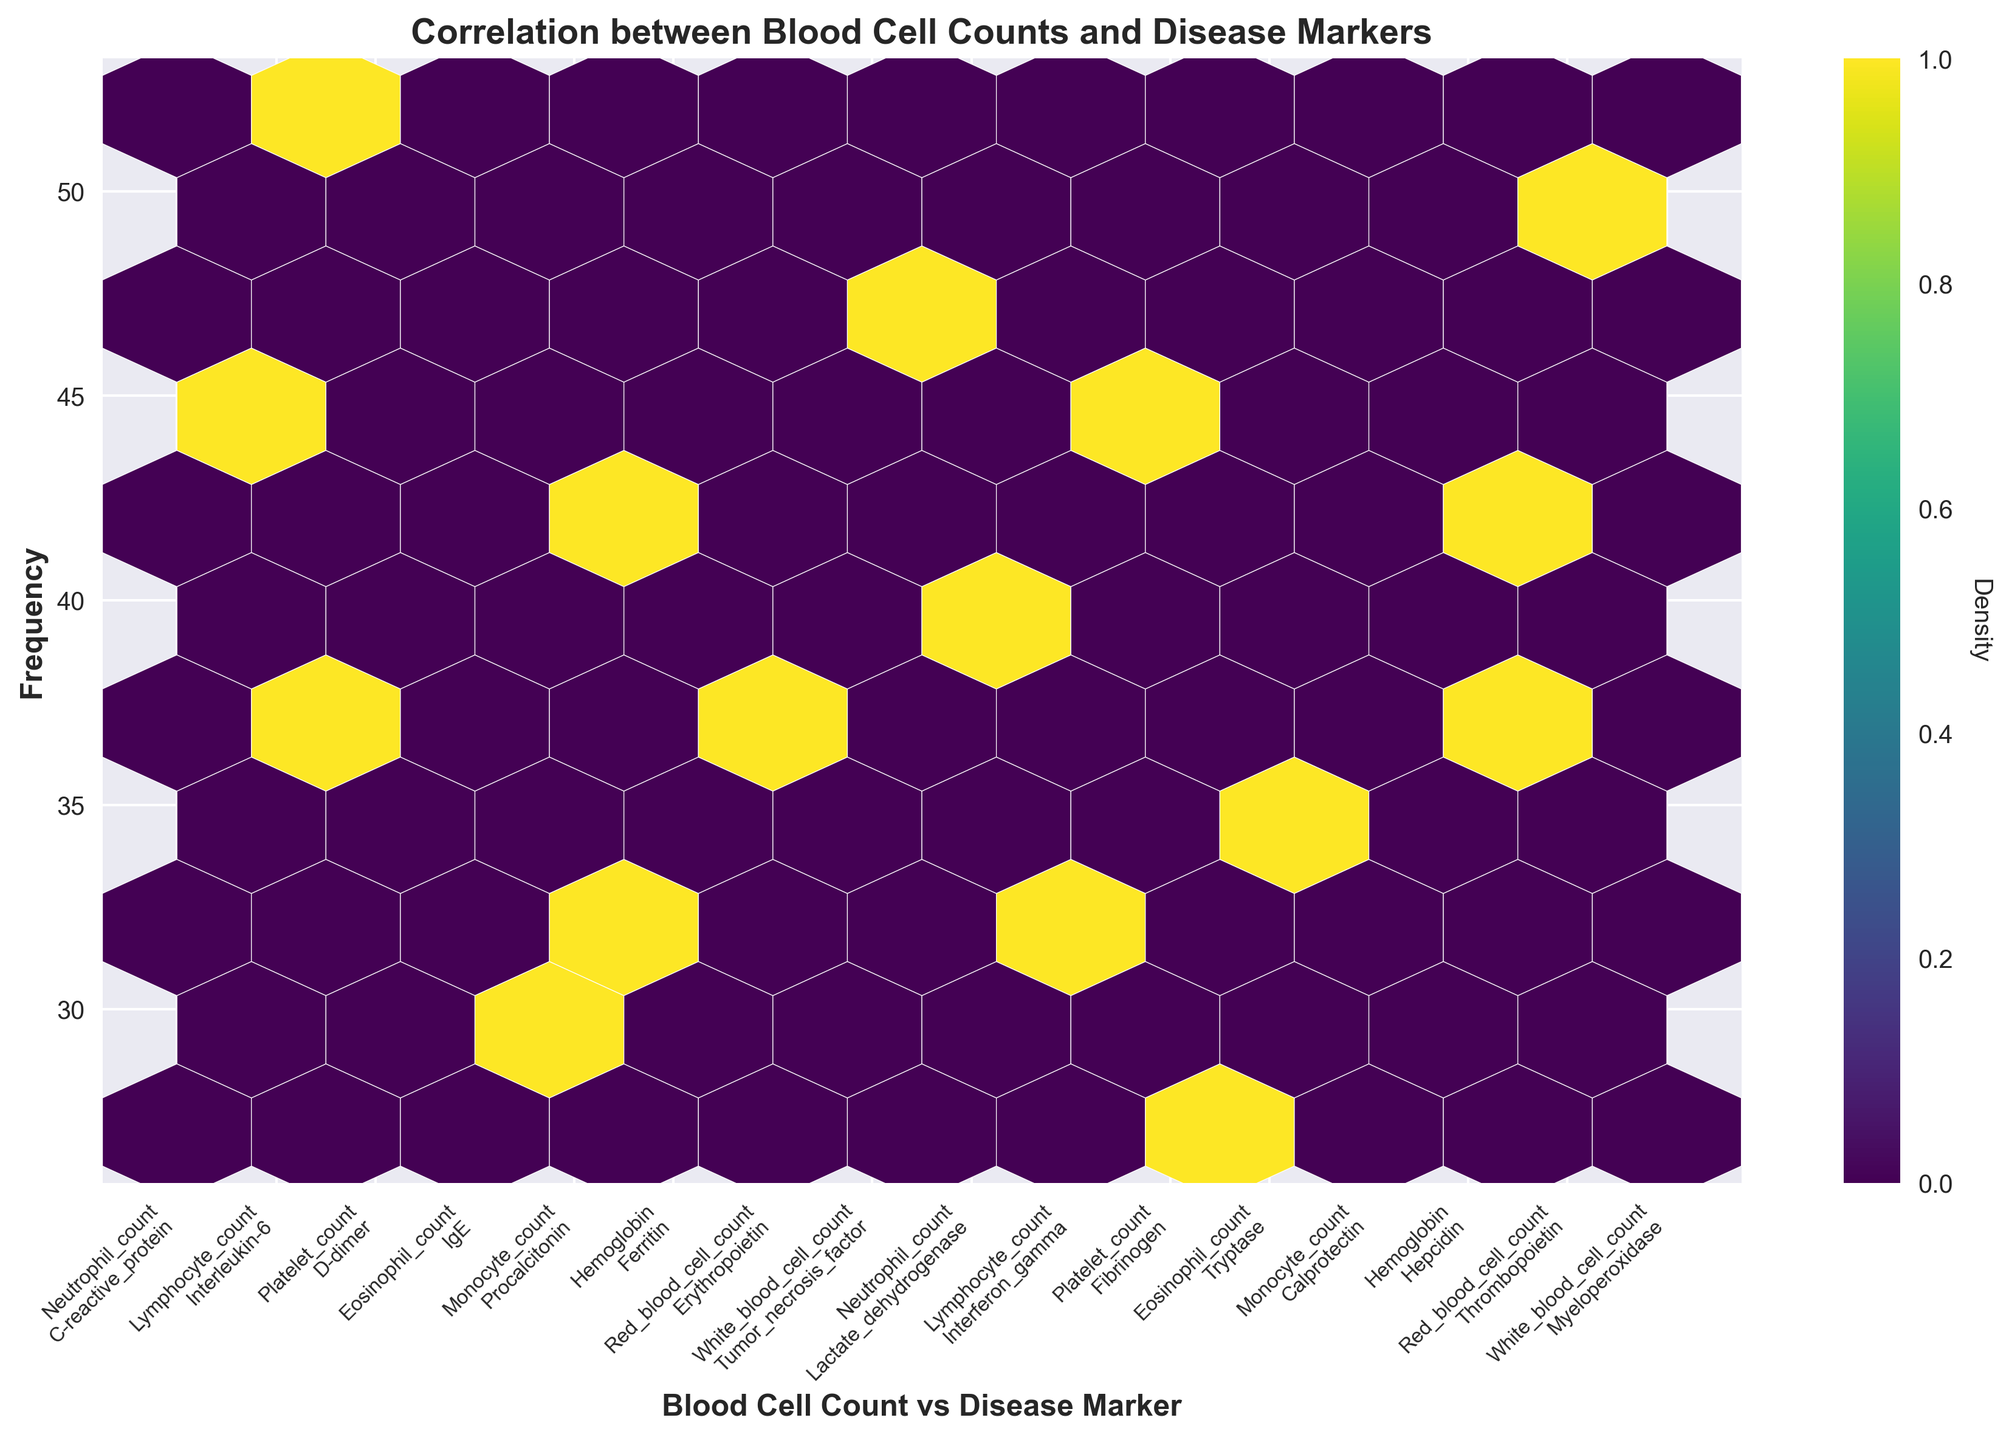What is the title of the hexbin plot? The title is displayed at the top-center of the plot and provides an overview of what the plot represents.
Answer: Correlation between Blood Cell Counts and Disease Markers What are the axes labels in the plot? The x-axis label is shown at the bottom and the y-axis label is shown on the left side of the plot.
Answer: Blood Cell Count vs Disease Marker (x-axis) and Frequency (y-axis) How many data points are presented in the hexbin plot? By counting the unique combinations of blood cell counts and disease markers on the x-axis, we find the total number of data points presented.
Answer: 16 Which blood cell count and disease marker combination has the highest frequency? By identifying the hexbin with the highest density, represented by the color intensity, we can find the combination with the highest count value.
Answer: Platelet count and D-dimer What is the frequency of the Neutrophil count and C-reactive protein combination? By locating the position of Neutrophil count and C-reactive protein on the x-axis and matching it to the corresponding hexbin, we can read the frequency value.
Answer: 45 Which combination has a higher frequency, Hemoglobin and Ferritin or Hemoglobin and Hepcidin? Compare the frequency values of both combinations by finding their positions on the x-axis and reading their respective hexbin densities.
Answer: Hemoglobin and Hepcidin Is the density of White blood cell count and Myeloperoxidase greater than Red blood cell count and Thrombopoietin? Compare the color intensity of the hexbins for the White blood cell count and Myeloperoxidase combination and the Red blood cell count and Thrombopoietin combination.
Answer: Yes Calculate the average frequency for all the combinations involving Neutrophil count. Identify the frequency values for Neutrophil count and its disease marker combinations, sum them up, and divide by the number of combinations. The combinations are Neutrophil count and C-reactive protein (45), and Neutrophil count and Lactate dehydrogenase (39). The sum is 45 + 39 = 84, and the average is 84 / 2.
Answer: 42 What are the tick labels on the x-axis in the hexbin plot? The x-axis tick labels are positioned below each pillar representing a combination of blood cell counts and disease markers, and each label shows both values separated by newline.
Answer: Neutrophil count\nC-reactive protein, Lymphocyte count\nInterleukin-6, Platelet count\nD-dimer, Eosinophil count\nIgE, Monocyte count\nProcalcitonin, Hemoglobin\nFerritin, Red blood cell count\nErythropoietin, White blood cell count\nTumor necrosis factor, Neutrophil count\nLactate dehydrogenase, Lymphocyte count\nInterferon gamma, Platelet count\nFibrinogen, Eosinophil count\nTryptase, Monocyte count\nCalprotectin, Hemoglobin\nHepcidin, Red blood cell count\nThrombopoietin, White blood cell count\nMyeloperoxidase How is density indicated in the hexbin plot? Density is indicated by the color of the hexbins, with a color bar on the right side of the plot showing the gradient from low to high density. The plot uses a 'viridis' color map to represent the density.
Answer: Color intensity 